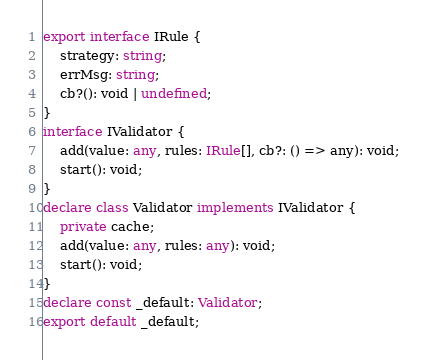Convert code to text. <code><loc_0><loc_0><loc_500><loc_500><_TypeScript_>export interface IRule {
    strategy: string;
    errMsg: string;
    cb?(): void | undefined;
}
interface IValidator {
    add(value: any, rules: IRule[], cb?: () => any): void;
    start(): void;
}
declare class Validator implements IValidator {
    private cache;
    add(value: any, rules: any): void;
    start(): void;
}
declare const _default: Validator;
export default _default;
</code> 